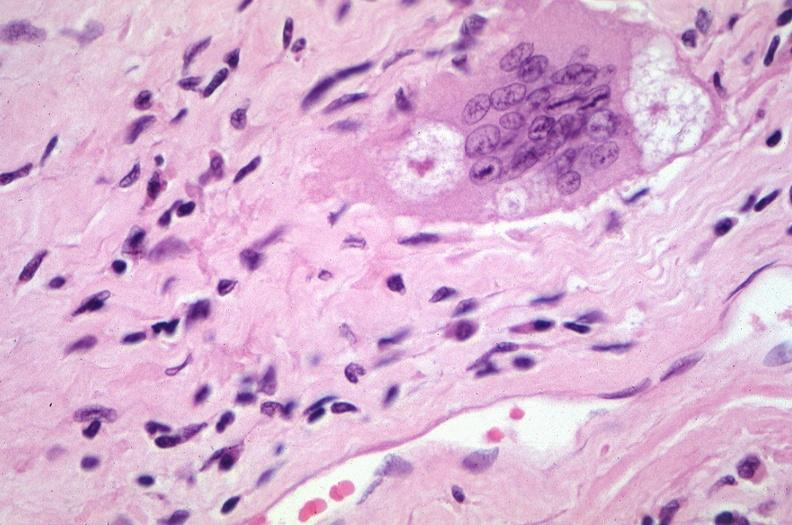where is this?
Answer the question using a single word or phrase. Lung 